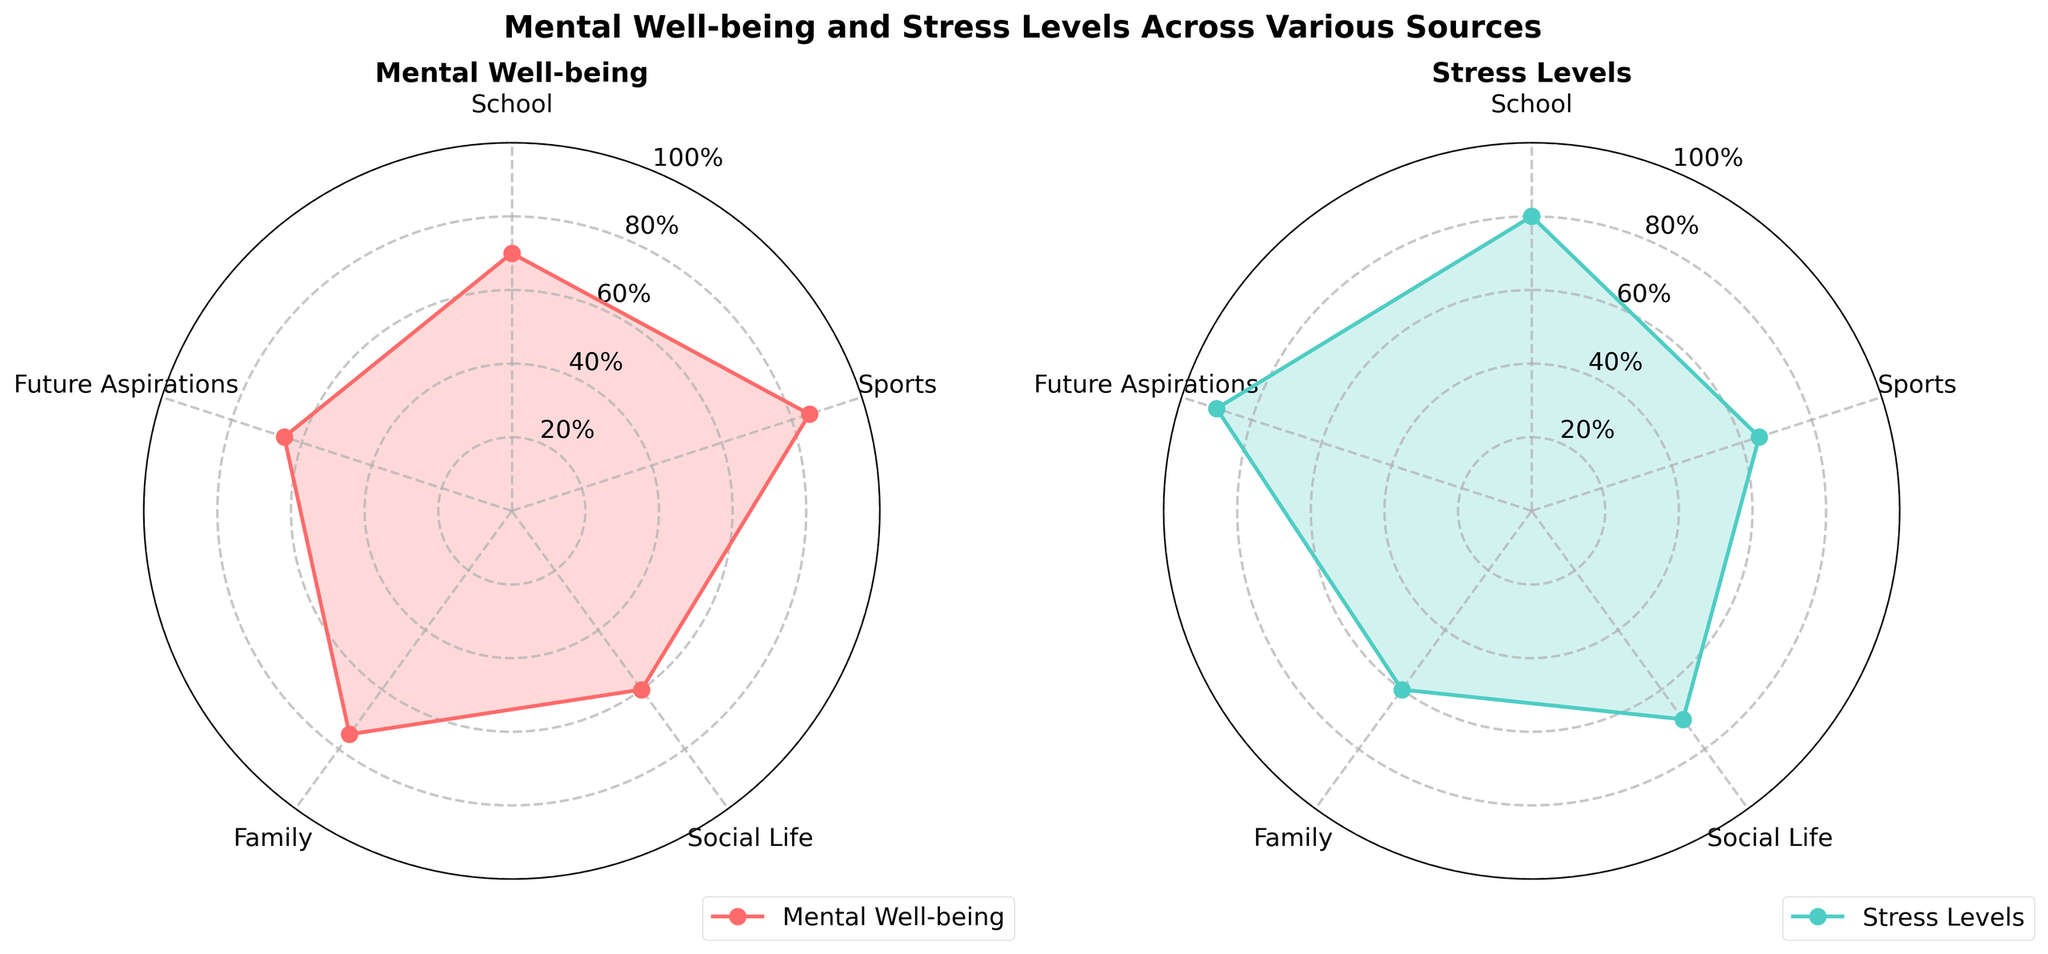What is the title of the figure? The figure title is written at the top, indicating the overall theme of the plot.
Answer: Mental Well-being and Stress Levels Across Various Sources What color represents Mental Well-being? The Mental Well-being data is plotted with a distinct color and labeled accordingly in the legend.
Answer: Red Which category has the highest stress level? By comparing the peaks of the Stress Levels (blue line) chart, the highest point determines the category.
Answer: Future Aspirations What is the range of percentage values used in these radar charts? The y-axis has percentage tick marks from a minimum to a maximum value.
Answer: 0% to 100% How many categories are being analyzed in the radar charts? By counting the number of labeled points around the radar chart.
Answer: 5 In which category is Mental Well-being the highest? Identify the peak value of the red line representing Mental Well-being across all categories.
Answer: Sports Compare Stress Levels in Sports and School. Refer to the values of the blue line at the categories "Sports" and "School" to determine which is higher.
Answer: School has higher stress levels than Sports What's the difference between Mental Well-being values in Sports and Social Life? Subtract the value of Mental Well-being in Social Life from that in Sports by observing the red line.
Answer: 25 By how much are Stress Levels in Future Aspirations higher than Mental Well-being in the same category? Subtract the Mental Well-being percentage in Future Aspirations from the Stress Level percentage in the same category.
Answer: 25 Which category indicates the greatest disparity between Mental Well-being and Stress Levels? By comparing the difference between the Mental Well-being and Stress Levels values in each category.
Answer: Future Aspirations 